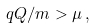<formula> <loc_0><loc_0><loc_500><loc_500>q Q / m > \mu \, ,</formula> 